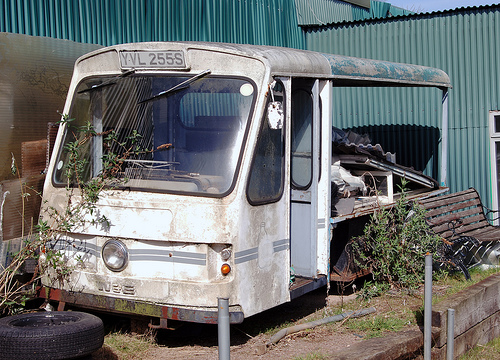<image>
Is the bush under the vehicle? Yes. The bush is positioned underneath the vehicle, with the vehicle above it in the vertical space. Is there a bus behind the sheet? No. The bus is not behind the sheet. From this viewpoint, the bus appears to be positioned elsewhere in the scene. 